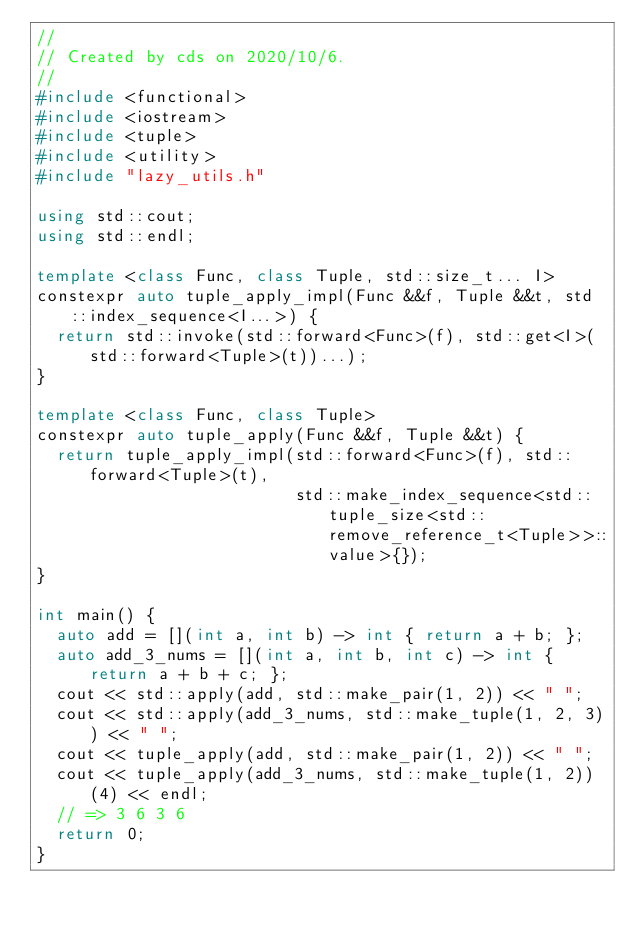Convert code to text. <code><loc_0><loc_0><loc_500><loc_500><_C++_>//
// Created by cds on 2020/10/6.
//
#include <functional>
#include <iostream>
#include <tuple>
#include <utility>
#include "lazy_utils.h"

using std::cout;
using std::endl;

template <class Func, class Tuple, std::size_t... I>
constexpr auto tuple_apply_impl(Func &&f, Tuple &&t, std::index_sequence<I...>) {
  return std::invoke(std::forward<Func>(f), std::get<I>(std::forward<Tuple>(t))...);
}

template <class Func, class Tuple>
constexpr auto tuple_apply(Func &&f, Tuple &&t) {
  return tuple_apply_impl(std::forward<Func>(f), std::forward<Tuple>(t),
                          std::make_index_sequence<std::tuple_size<std::remove_reference_t<Tuple>>::value>{});
}

int main() {
  auto add = [](int a, int b) -> int { return a + b; };
  auto add_3_nums = [](int a, int b, int c) -> int { return a + b + c; };
  cout << std::apply(add, std::make_pair(1, 2)) << " ";
  cout << std::apply(add_3_nums, std::make_tuple(1, 2, 3)) << " ";
  cout << tuple_apply(add, std::make_pair(1, 2)) << " ";
  cout << tuple_apply(add_3_nums, std::make_tuple(1, 2))(4) << endl;
  // => 3 6 3 6
  return 0;
}</code> 